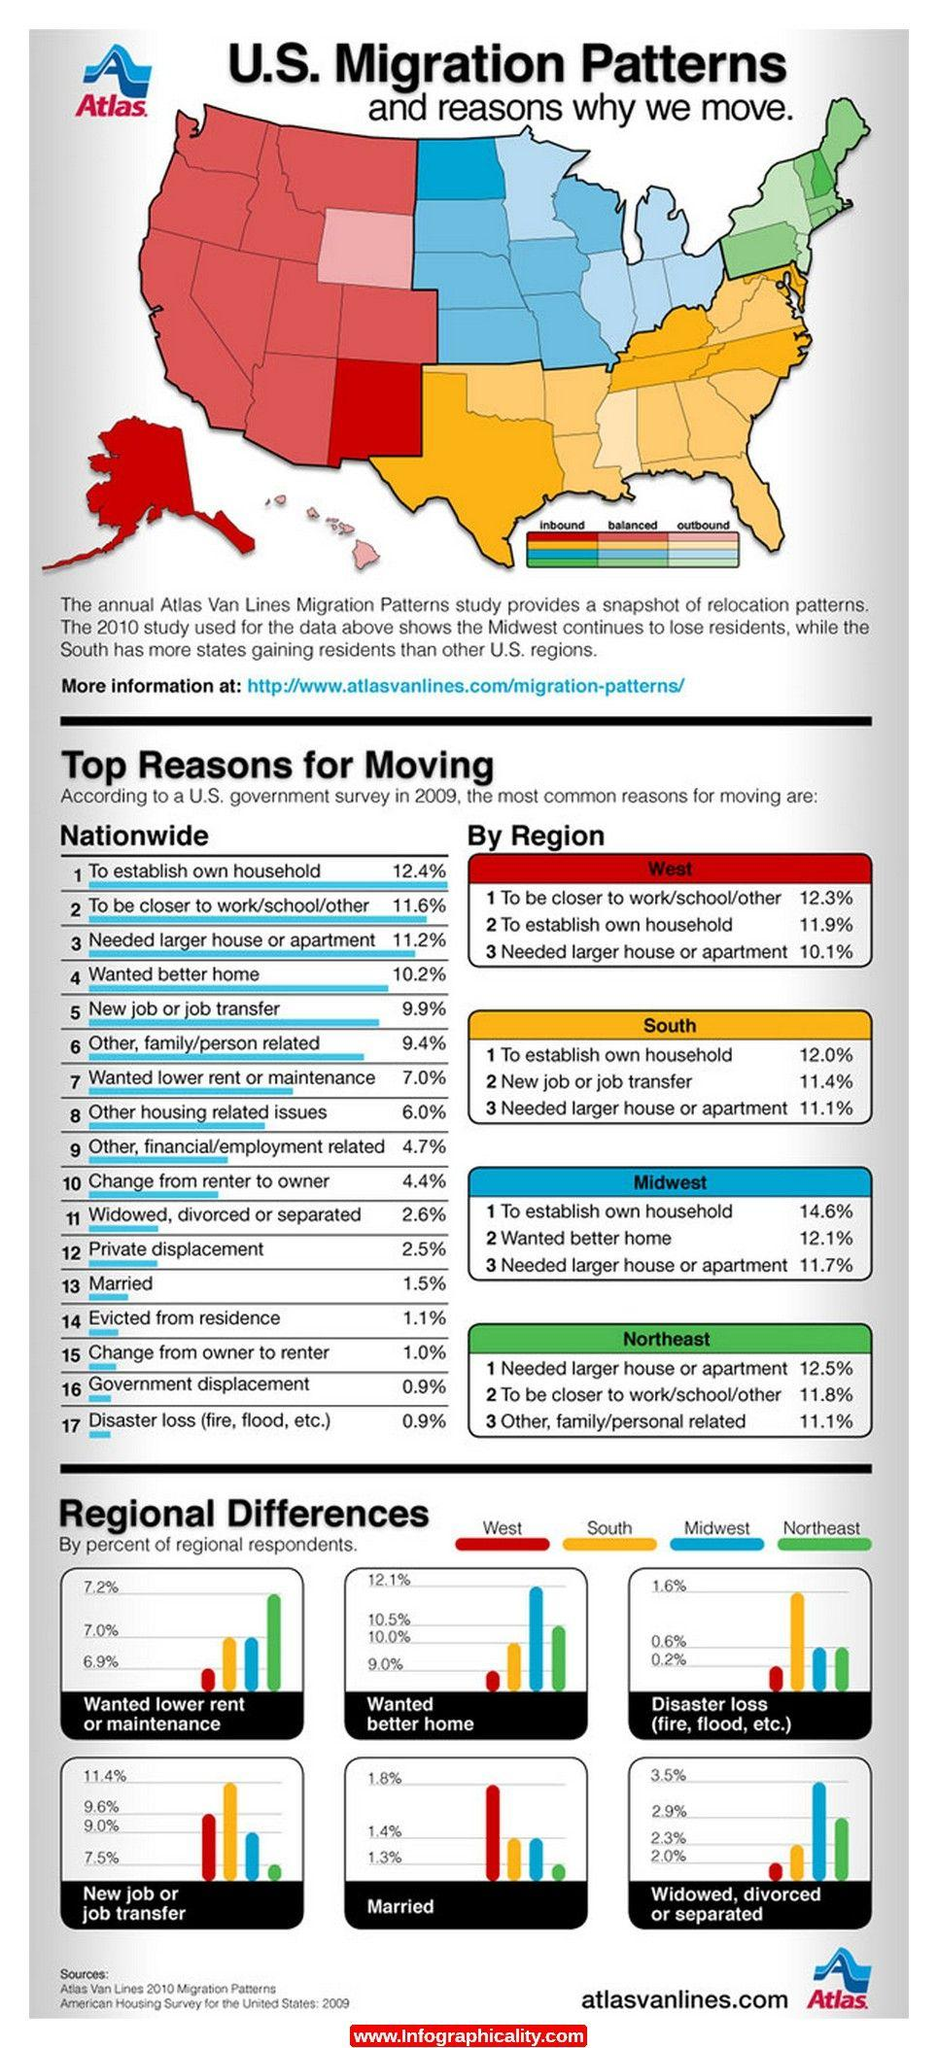Give some essential details in this illustration. According to the given data, only 0.9% of the population moved due to government displacement or disaster loss, highlighting the limited impact of these factors on population mobility. The common reason for people to move in all four regions was due to the desire for a larger house, to accommodate their growing families, job transfers, or relocation for work. Approximately 11.4% of migration in the South was due to job transfers. According to the data, the region with the lowest percentage of people moving for better homes was the West. Between Alaska and New Mexico, which state has a higher rate of inbound migration? 